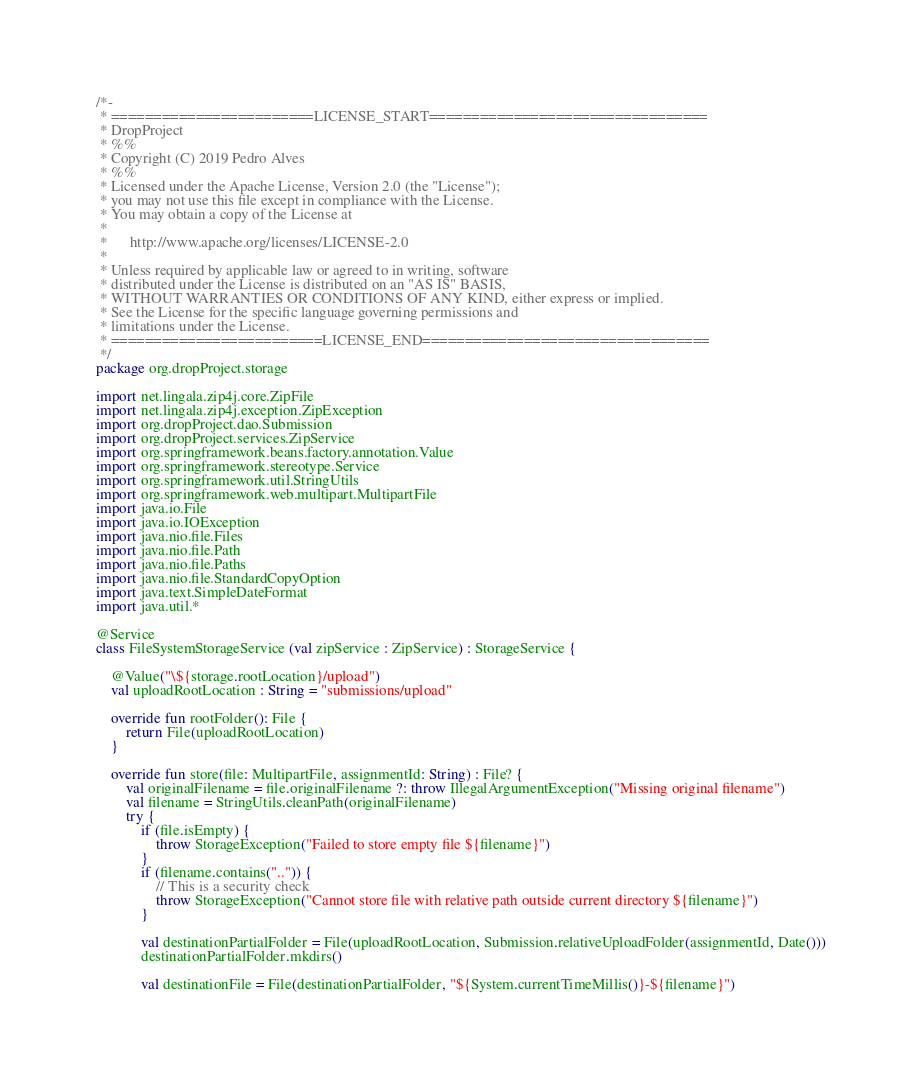<code> <loc_0><loc_0><loc_500><loc_500><_Kotlin_>/*-
 * ========================LICENSE_START=================================
 * DropProject
 * %%
 * Copyright (C) 2019 Pedro Alves
 * %%
 * Licensed under the Apache License, Version 2.0 (the "License");
 * you may not use this file except in compliance with the License.
 * You may obtain a copy of the License at
 * 
 *      http://www.apache.org/licenses/LICENSE-2.0
 * 
 * Unless required by applicable law or agreed to in writing, software
 * distributed under the License is distributed on an "AS IS" BASIS,
 * WITHOUT WARRANTIES OR CONDITIONS OF ANY KIND, either express or implied.
 * See the License for the specific language governing permissions and
 * limitations under the License.
 * =========================LICENSE_END==================================
 */
package org.dropProject.storage

import net.lingala.zip4j.core.ZipFile
import net.lingala.zip4j.exception.ZipException
import org.dropProject.dao.Submission
import org.dropProject.services.ZipService
import org.springframework.beans.factory.annotation.Value
import org.springframework.stereotype.Service
import org.springframework.util.StringUtils
import org.springframework.web.multipart.MultipartFile
import java.io.File
import java.io.IOException
import java.nio.file.Files
import java.nio.file.Path
import java.nio.file.Paths
import java.nio.file.StandardCopyOption
import java.text.SimpleDateFormat
import java.util.*

@Service
class FileSystemStorageService (val zipService : ZipService) : StorageService {

    @Value("\${storage.rootLocation}/upload")
    val uploadRootLocation : String = "submissions/upload"

    override fun rootFolder(): File {
        return File(uploadRootLocation)
    }

    override fun store(file: MultipartFile, assignmentId: String) : File? {
        val originalFilename = file.originalFilename ?: throw IllegalArgumentException("Missing original filename")
        val filename = StringUtils.cleanPath(originalFilename)
        try {
            if (file.isEmpty) {
                throw StorageException("Failed to store empty file ${filename}")
            }
            if (filename.contains("..")) {
                // This is a security check
                throw StorageException("Cannot store file with relative path outside current directory ${filename}")
            }

            val destinationPartialFolder = File(uploadRootLocation, Submission.relativeUploadFolder(assignmentId, Date()))
            destinationPartialFolder.mkdirs()

            val destinationFile = File(destinationPartialFolder, "${System.currentTimeMillis()}-${filename}")</code> 